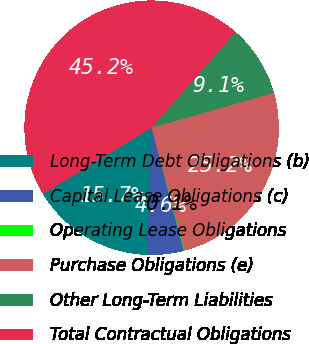Convert chart. <chart><loc_0><loc_0><loc_500><loc_500><pie_chart><fcel>Long-Term Debt Obligations (b)<fcel>Capital Lease Obligations (c)<fcel>Operating Lease Obligations<fcel>Purchase Obligations (e)<fcel>Other Long-Term Liabilities<fcel>Total Contractual Obligations<nl><fcel>15.73%<fcel>4.62%<fcel>0.11%<fcel>25.23%<fcel>9.13%<fcel>45.19%<nl></chart> 